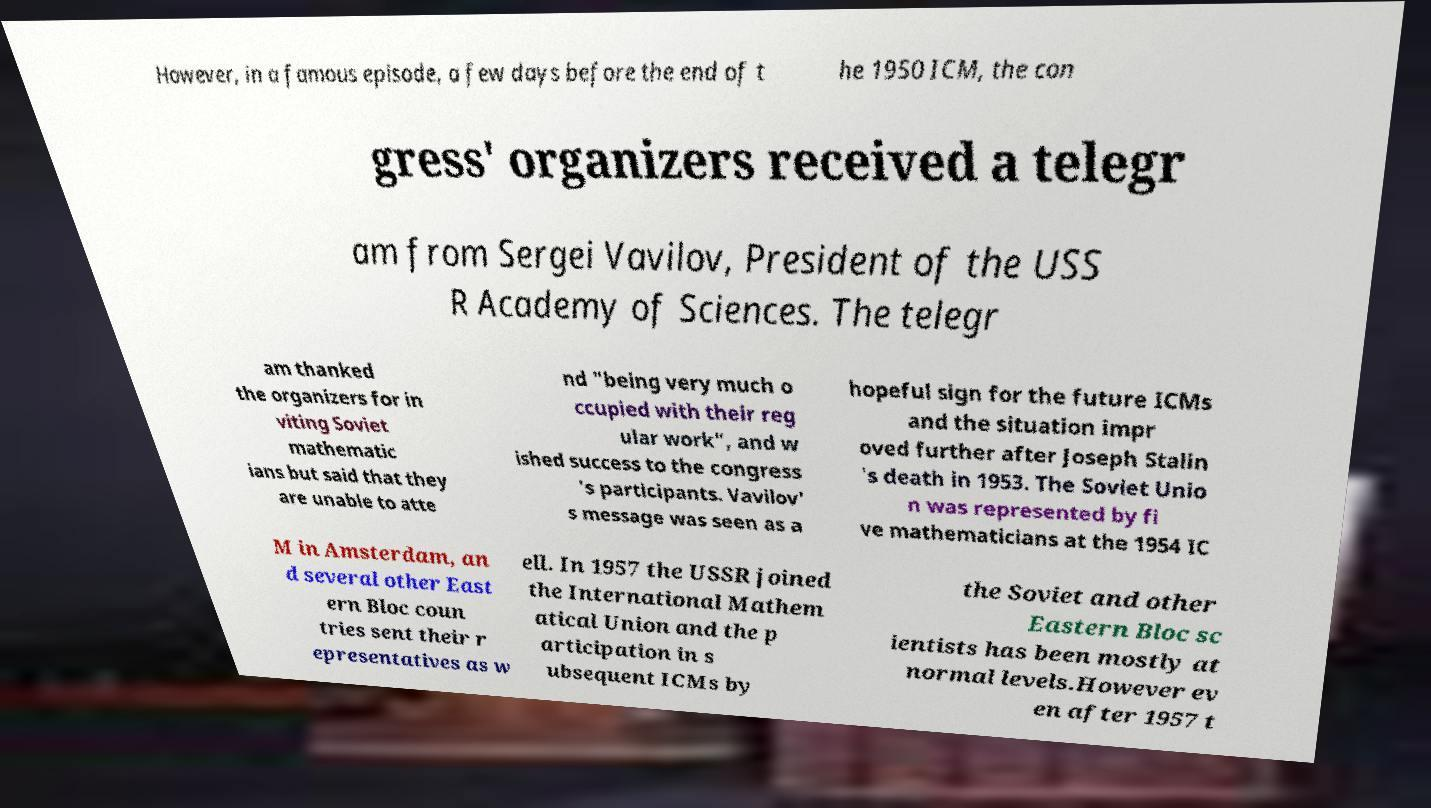For documentation purposes, I need the text within this image transcribed. Could you provide that? However, in a famous episode, a few days before the end of t he 1950 ICM, the con gress' organizers received a telegr am from Sergei Vavilov, President of the USS R Academy of Sciences. The telegr am thanked the organizers for in viting Soviet mathematic ians but said that they are unable to atte nd "being very much o ccupied with their reg ular work", and w ished success to the congress 's participants. Vavilov' s message was seen as a hopeful sign for the future ICMs and the situation impr oved further after Joseph Stalin 's death in 1953. The Soviet Unio n was represented by fi ve mathematicians at the 1954 IC M in Amsterdam, an d several other East ern Bloc coun tries sent their r epresentatives as w ell. In 1957 the USSR joined the International Mathem atical Union and the p articipation in s ubsequent ICMs by the Soviet and other Eastern Bloc sc ientists has been mostly at normal levels.However ev en after 1957 t 